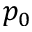<formula> <loc_0><loc_0><loc_500><loc_500>p _ { 0 }</formula> 